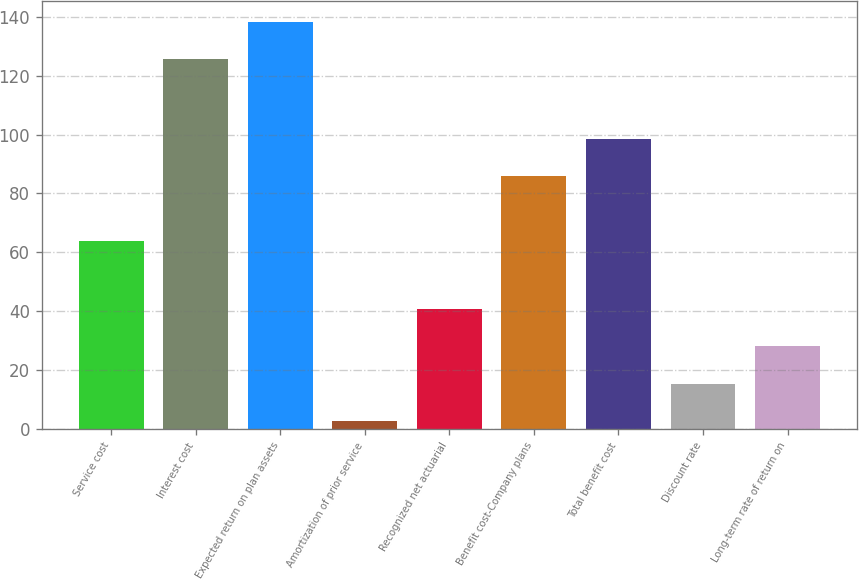Convert chart to OTSL. <chart><loc_0><loc_0><loc_500><loc_500><bar_chart><fcel>Service cost<fcel>Interest cost<fcel>Expected return on plan assets<fcel>Amortization of prior service<fcel>Recognized net actuarial<fcel>Benefit cost-Company plans<fcel>Total benefit cost<fcel>Discount rate<fcel>Long-term rate of return on<nl><fcel>63.7<fcel>125.6<fcel>138.29<fcel>2.7<fcel>40.77<fcel>85.8<fcel>98.49<fcel>15.39<fcel>28.08<nl></chart> 